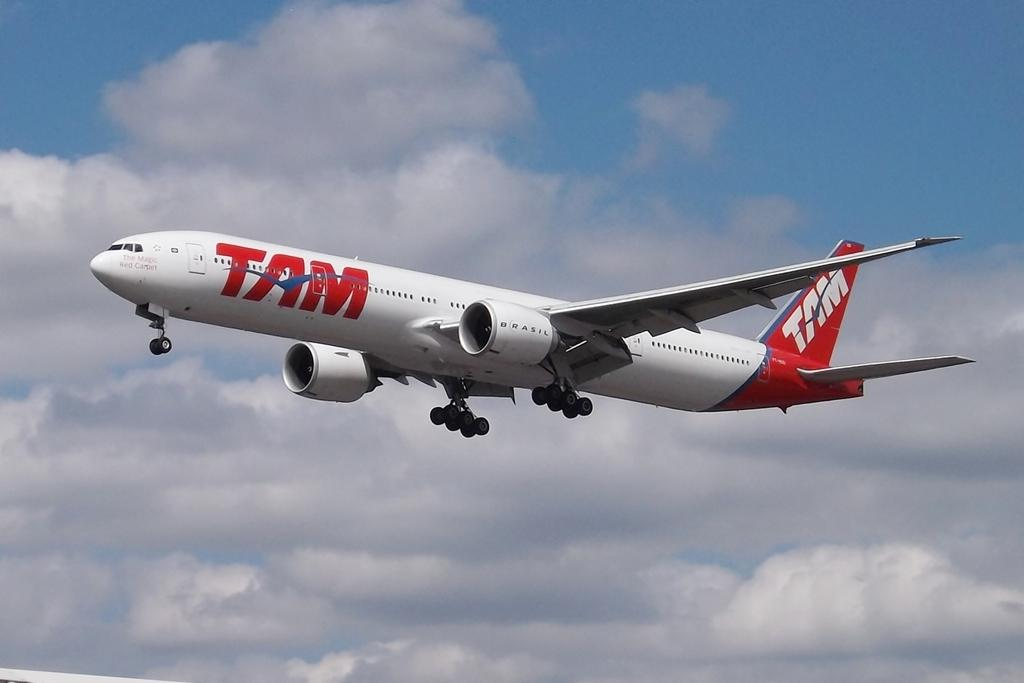<image>
Provide a brief description of the given image. A TAM airlines plane takes flight into the sky. 